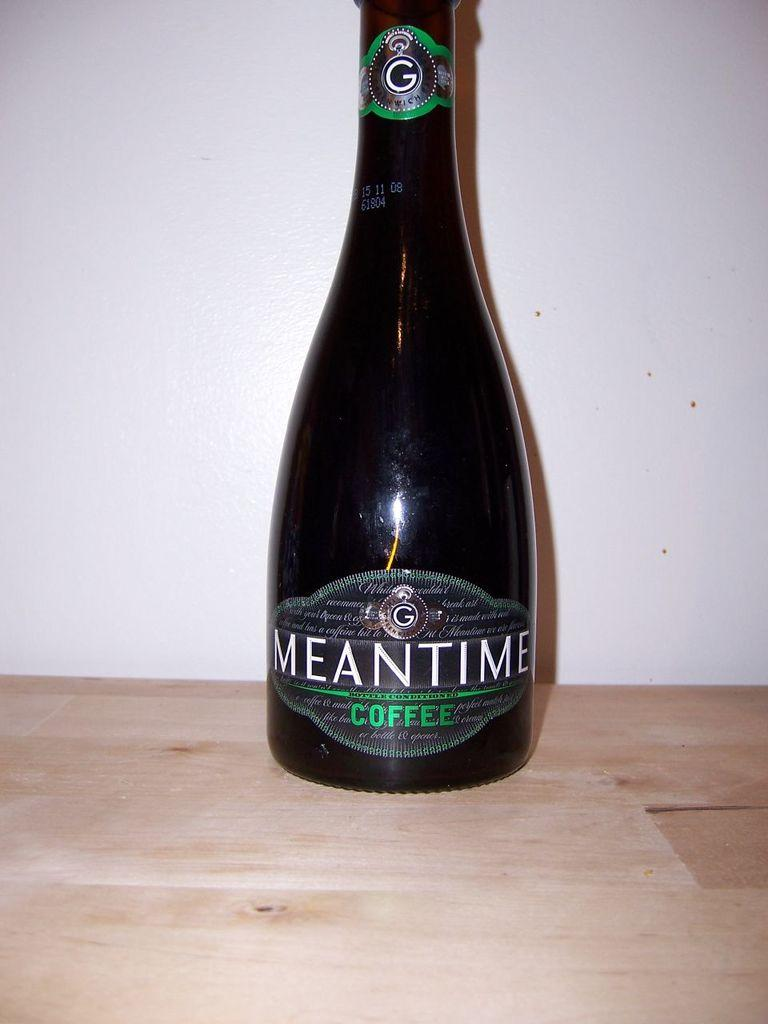What is the main object in the image? There is a wine bottle in the image. What is the color of the surface the wine bottle is on? The wine bottle is on a brown surface. What is written on the wine bottle? The name "Mean Time" is written on the wine bottle. What can be seen in the background of the image? There is a white wall in the background of the image. What type of loaf is being used to open the wine bottle in the image? There is no loaf present in the image, and the wine bottle is not being opened. 